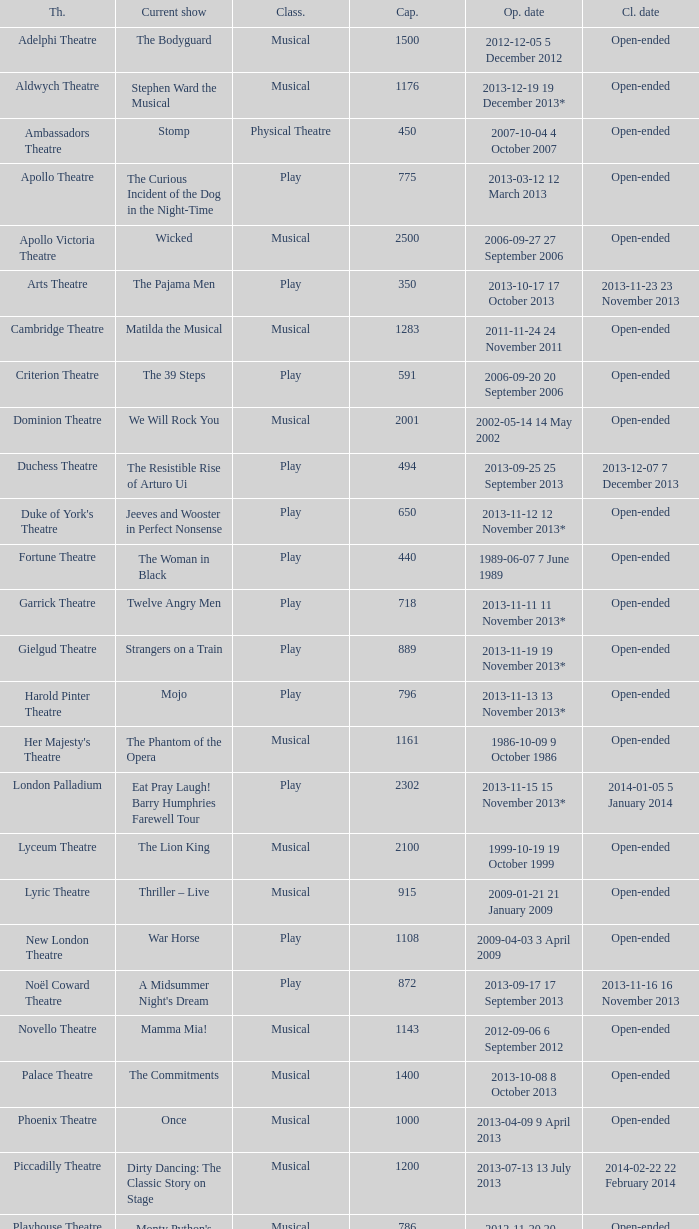What opening date has a capacity of 100? 2013-11-01 1 November 2013. Could you parse the entire table as a dict? {'header': ['Th.', 'Current show', 'Class.', 'Cap.', 'Op. date', 'Cl. date'], 'rows': [['Adelphi Theatre', 'The Bodyguard', 'Musical', '1500', '2012-12-05 5 December 2012', 'Open-ended'], ['Aldwych Theatre', 'Stephen Ward the Musical', 'Musical', '1176', '2013-12-19 19 December 2013*', 'Open-ended'], ['Ambassadors Theatre', 'Stomp', 'Physical Theatre', '450', '2007-10-04 4 October 2007', 'Open-ended'], ['Apollo Theatre', 'The Curious Incident of the Dog in the Night-Time', 'Play', '775', '2013-03-12 12 March 2013', 'Open-ended'], ['Apollo Victoria Theatre', 'Wicked', 'Musical', '2500', '2006-09-27 27 September 2006', 'Open-ended'], ['Arts Theatre', 'The Pajama Men', 'Play', '350', '2013-10-17 17 October 2013', '2013-11-23 23 November 2013'], ['Cambridge Theatre', 'Matilda the Musical', 'Musical', '1283', '2011-11-24 24 November 2011', 'Open-ended'], ['Criterion Theatre', 'The 39 Steps', 'Play', '591', '2006-09-20 20 September 2006', 'Open-ended'], ['Dominion Theatre', 'We Will Rock You', 'Musical', '2001', '2002-05-14 14 May 2002', 'Open-ended'], ['Duchess Theatre', 'The Resistible Rise of Arturo Ui', 'Play', '494', '2013-09-25 25 September 2013', '2013-12-07 7 December 2013'], ["Duke of York's Theatre", 'Jeeves and Wooster in Perfect Nonsense', 'Play', '650', '2013-11-12 12 November 2013*', 'Open-ended'], ['Fortune Theatre', 'The Woman in Black', 'Play', '440', '1989-06-07 7 June 1989', 'Open-ended'], ['Garrick Theatre', 'Twelve Angry Men', 'Play', '718', '2013-11-11 11 November 2013*', 'Open-ended'], ['Gielgud Theatre', 'Strangers on a Train', 'Play', '889', '2013-11-19 19 November 2013*', 'Open-ended'], ['Harold Pinter Theatre', 'Mojo', 'Play', '796', '2013-11-13 13 November 2013*', 'Open-ended'], ["Her Majesty's Theatre", 'The Phantom of the Opera', 'Musical', '1161', '1986-10-09 9 October 1986', 'Open-ended'], ['London Palladium', 'Eat Pray Laugh! Barry Humphries Farewell Tour', 'Play', '2302', '2013-11-15 15 November 2013*', '2014-01-05 5 January 2014'], ['Lyceum Theatre', 'The Lion King', 'Musical', '2100', '1999-10-19 19 October 1999', 'Open-ended'], ['Lyric Theatre', 'Thriller – Live', 'Musical', '915', '2009-01-21 21 January 2009', 'Open-ended'], ['New London Theatre', 'War Horse', 'Play', '1108', '2009-04-03 3 April 2009', 'Open-ended'], ['Noël Coward Theatre', "A Midsummer Night's Dream", 'Play', '872', '2013-09-17 17 September 2013', '2013-11-16 16 November 2013'], ['Novello Theatre', 'Mamma Mia!', 'Musical', '1143', '2012-09-06 6 September 2012', 'Open-ended'], ['Palace Theatre', 'The Commitments', 'Musical', '1400', '2013-10-08 8 October 2013', 'Open-ended'], ['Phoenix Theatre', 'Once', 'Musical', '1000', '2013-04-09 9 April 2013', 'Open-ended'], ['Piccadilly Theatre', 'Dirty Dancing: The Classic Story on Stage', 'Musical', '1200', '2013-07-13 13 July 2013', '2014-02-22 22 February 2014'], ['Playhouse Theatre', "Monty Python's Spamalot", 'Musical', '786', '2012-11-20 20 November 2012', 'Open-ended'], ['Prince Edward Theatre', 'Jersey Boys', 'Musical', '1618', '2008-03-18 18 March 2008', '2014-03-09 9 March 2014'], ['Prince of Wales Theatre', 'The Book of Mormon', 'Musical', '1160', '2013-03-21 21 March 2013', 'Open-ended'], ["Queen's Theatre", 'Les Misérables', 'Musical', '1099', '2004-04-12 12 April 2004', 'Open-ended'], ['Savoy Theatre', 'Let It Be', 'Musical', '1158', '2013-02-01 1 February 2013', 'Open-ended'], ['Shaftesbury Theatre', 'From Here to Eternity the Musical', 'Musical', '1400', '2013-10-23 23 October 2013', 'Open-ended'], ['St. James Theatre', 'Scenes from a Marriage', 'Play', '312', '2013-09-11 11 September 2013', '2013-11-9 9 November 2013'], ["St Martin's Theatre", 'The Mousetrap', 'Play', '550', '1974-03-25 25 March 1974', 'Open-ended'], ['Theatre Royal, Haymarket', 'One Man, Two Guvnors', 'Play', '888', '2012-03-02 2 March 2012', '2013-03-01 1 March 2014'], ['Theatre Royal, Drury Lane', 'Charlie and the Chocolate Factory the Musical', 'Musical', '2220', '2013-06-25 25 June 2013', 'Open-ended'], ['Trafalgar Studios 1', 'The Pride', 'Play', '380', '2013-08-13 13 August 2013', '2013-11-23 23 November 2013'], ['Trafalgar Studios 2', 'Mrs. Lowry and Son', 'Play', '100', '2013-11-01 1 November 2013', '2013-11-23 23 November 2013'], ['Vaudeville Theatre', 'The Ladykillers', 'Play', '681', '2013-07-09 9 July 2013', '2013-11-16 16 November 2013'], ['Victoria Palace Theatre', 'Billy Elliot the Musical', 'Musical', '1517', '2005-05-11 11 May 2005', 'Open-ended'], ["Wyndham's Theatre", 'Barking in Essex', 'Play', '750', '2013-09-16 16 September 2013', '2014-01-04 4 January 2014']]} 